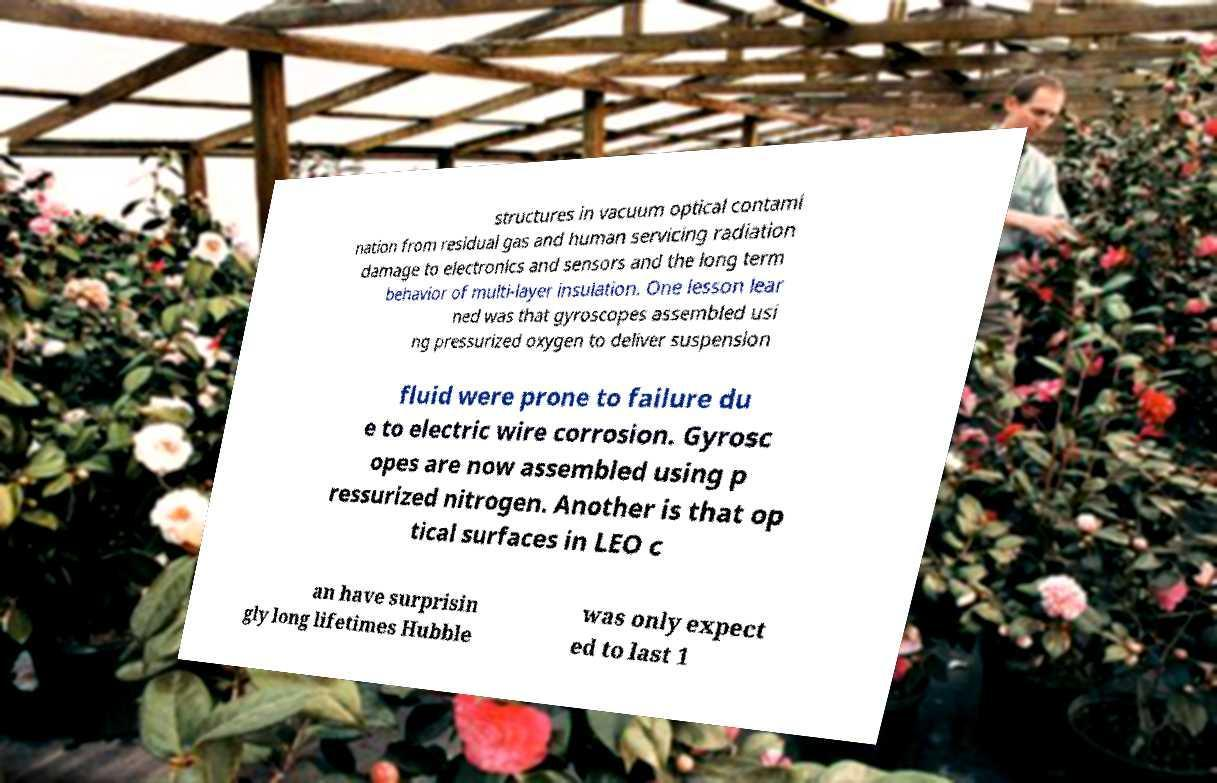Please identify and transcribe the text found in this image. structures in vacuum optical contami nation from residual gas and human servicing radiation damage to electronics and sensors and the long term behavior of multi-layer insulation. One lesson lear ned was that gyroscopes assembled usi ng pressurized oxygen to deliver suspension fluid were prone to failure du e to electric wire corrosion. Gyrosc opes are now assembled using p ressurized nitrogen. Another is that op tical surfaces in LEO c an have surprisin gly long lifetimes Hubble was only expect ed to last 1 